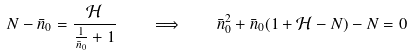Convert formula to latex. <formula><loc_0><loc_0><loc_500><loc_500>N - \bar { n } _ { 0 } = \frac { \mathcal { H } } { \frac { 1 } { \bar { n } _ { 0 } } + 1 } \quad \Longrightarrow \quad \bar { n } _ { 0 } ^ { 2 } + \bar { n } _ { 0 } ( 1 + \mathcal { H } - N ) - N = 0</formula> 